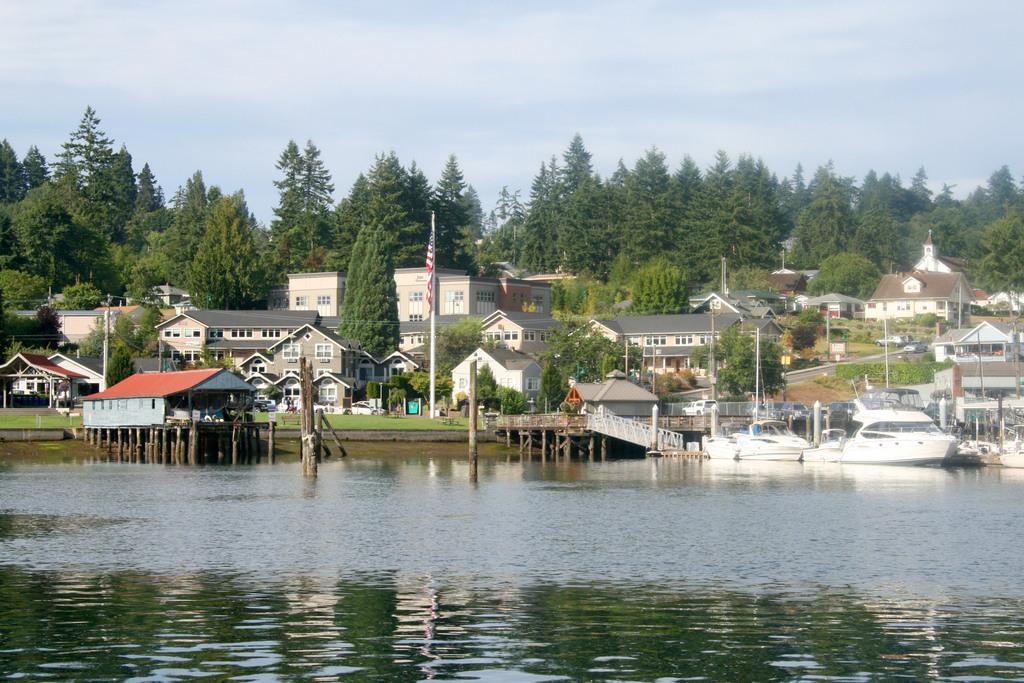What types of vehicles can be seen in the image? There are vehicles in the image, but the specific types are not mentioned in the facts. What is the primary mode of transportation in the image? Boats can be seen in the image, suggesting that water-based transportation is a primary mode. What structures are present in the image? There are buildings, flagpoles, houses, and trees in the image. What is the setting of the image? The image features a combination of urban and natural elements, including buildings, roads, and trees. What is visible at the top of the image? The sky is visible in the image. What is located at the bottom of the image? There is water at the bottom of the image. Where is the toothbrush located in the image? There is no toothbrush present in the image. What direction is the building facing in the image? The facts do not provide information about the presence of buildings, but not their orientation or direction. 